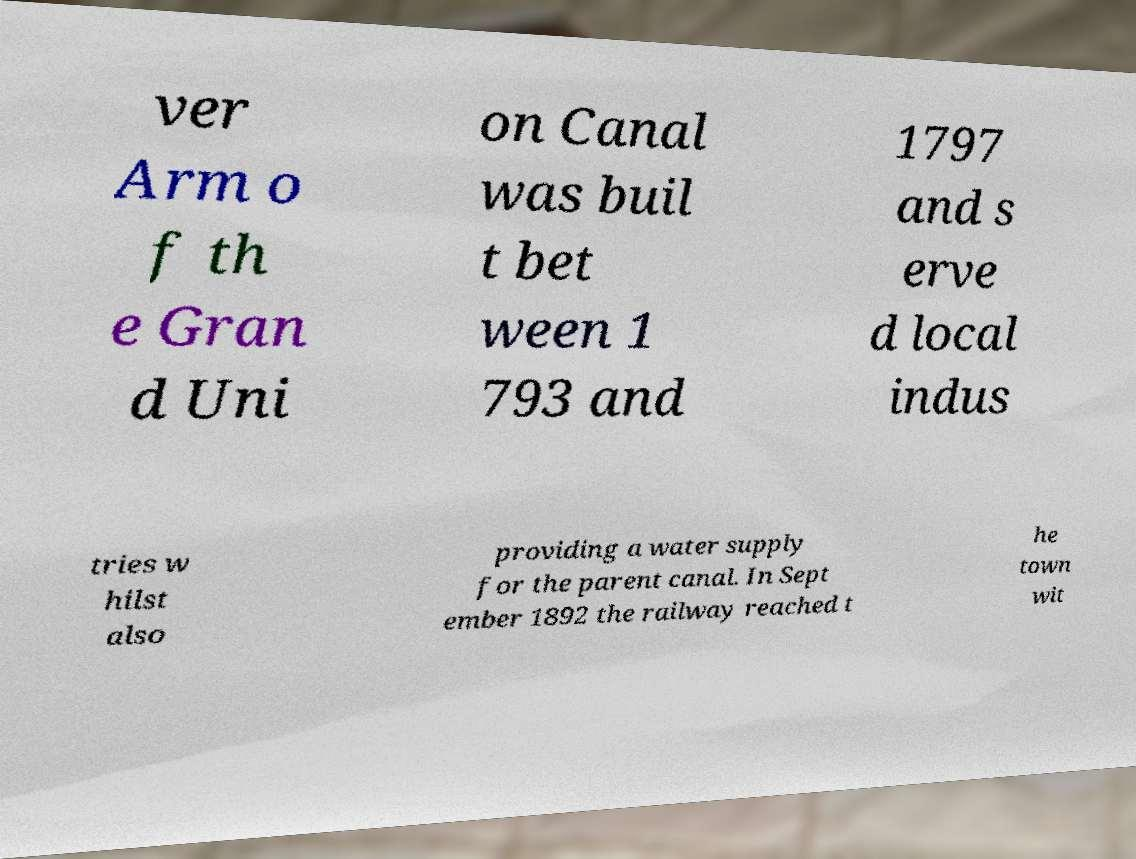Could you extract and type out the text from this image? ver Arm o f th e Gran d Uni on Canal was buil t bet ween 1 793 and 1797 and s erve d local indus tries w hilst also providing a water supply for the parent canal. In Sept ember 1892 the railway reached t he town wit 